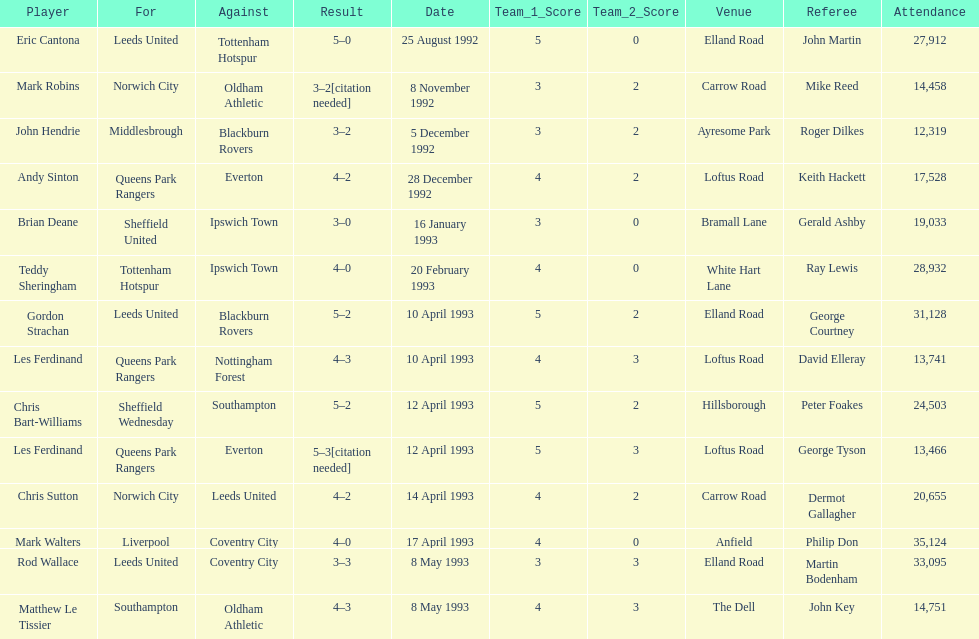Which team does john hendrie represent? Middlesbrough. 